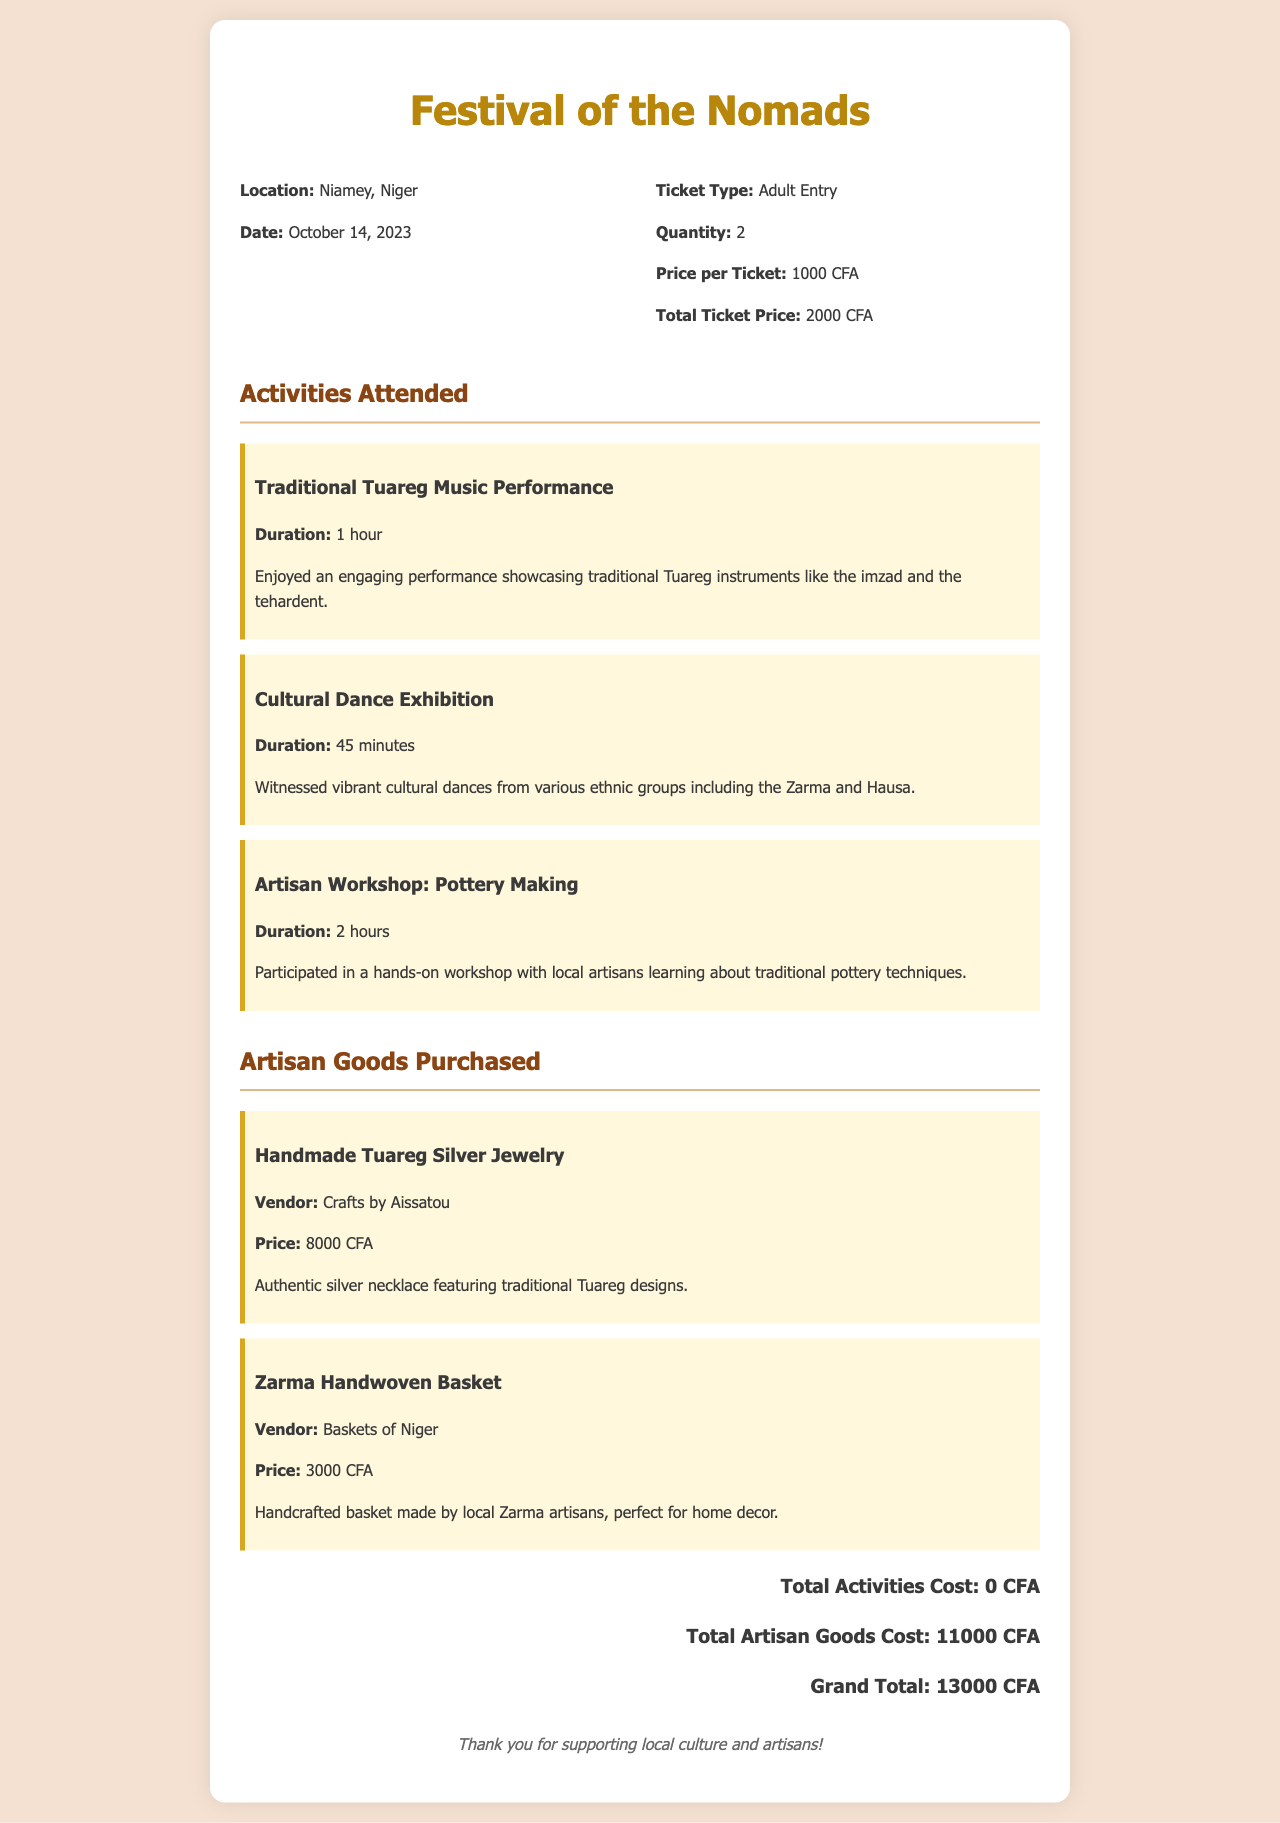What is the location of the festival? The location is explicitly mentioned in the document as Niamey, Niger.
Answer: Niamey, Niger What is the date of the festival? The date when the festival took place is stated as October 14, 2023.
Answer: October 14, 2023 How many tickets were purchased? The document states that 2 tickets were purchased for entry.
Answer: 2 What is the total price for the tickets? The total ticket price is calculated as 2000 CFA for the two tickets, as indicated in the document.
Answer: 2000 CFA What activity lasted for 2 hours? The hands-on workshop for pottery making is mentioned with a duration of 2 hours.
Answer: Pottery Making How much did the handmade Tuareg silver jewelry cost? The price for the handmade Tuareg silver jewelry is stated as 8000 CFA in the artisan goods section.
Answer: 8000 CFA What is the total cost for artisan goods purchased? The total cost for the artisan goods is the sum of the prices listed, amounting to 11000 CFA.
Answer: 11000 CFA What type of activity was the Cultural Dance Exhibition? The Cultural Dance Exhibition is categorized as a cultural performance showcasing dances from various ethnic groups.
Answer: Cultural Dance Exhibition What vendor sold the Zarma handwoven basket? The vendor mentioned in the document for the Zarma handwoven basket is "Baskets of Niger."
Answer: Baskets of Niger 